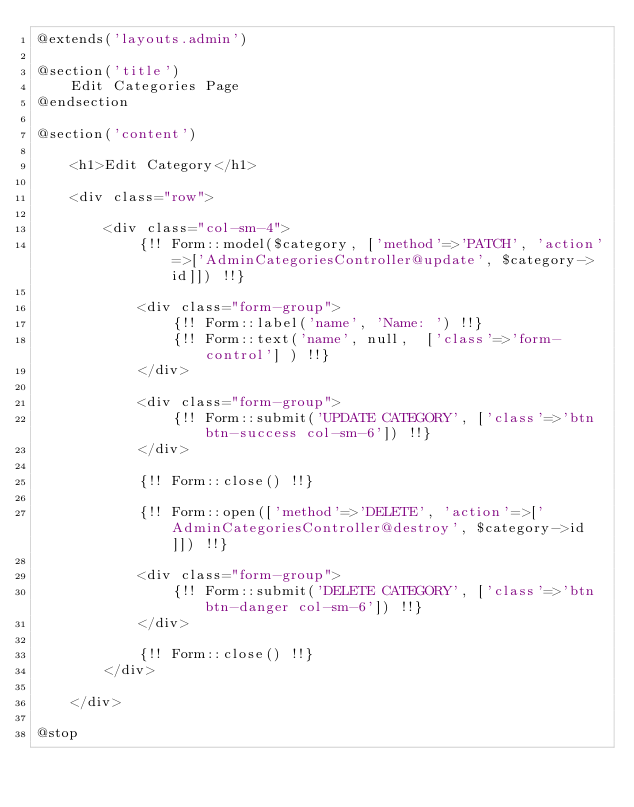<code> <loc_0><loc_0><loc_500><loc_500><_PHP_>@extends('layouts.admin')

@section('title')
    Edit Categories Page
@endsection

@section('content')

    <h1>Edit Category</h1>

    <div class="row">

        <div class="col-sm-4">
            {!! Form::model($category, ['method'=>'PATCH', 'action'=>['AdminCategoriesController@update', $category->id]]) !!}

            <div class="form-group">
                {!! Form::label('name', 'Name: ') !!}
                {!! Form::text('name', null,  ['class'=>'form-control'] ) !!}
            </div>

            <div class="form-group">
                {!! Form::submit('UPDATE CATEGORY', ['class'=>'btn btn-success col-sm-6']) !!}
            </div>

            {!! Form::close() !!}

            {!! Form::open(['method'=>'DELETE', 'action'=>['AdminCategoriesController@destroy', $category->id]]) !!}

            <div class="form-group">
                {!! Form::submit('DELETE CATEGORY', ['class'=>'btn btn-danger col-sm-6']) !!}
            </div>

            {!! Form::close() !!}
        </div>

    </div>

@stop
</code> 